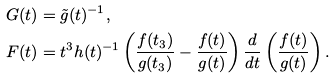<formula> <loc_0><loc_0><loc_500><loc_500>G ( t ) & = \tilde { g } ( t ) ^ { - 1 } , \\ F ( t ) & = t ^ { 3 } h ( t ) ^ { - 1 } \left ( \frac { f ( t _ { 3 } ) } { g ( t _ { 3 } ) } - \frac { f ( t ) } { g ( t ) } \right ) \frac { d } { d t } \left ( \frac { f ( t ) } { g ( t ) } \right ) .</formula> 